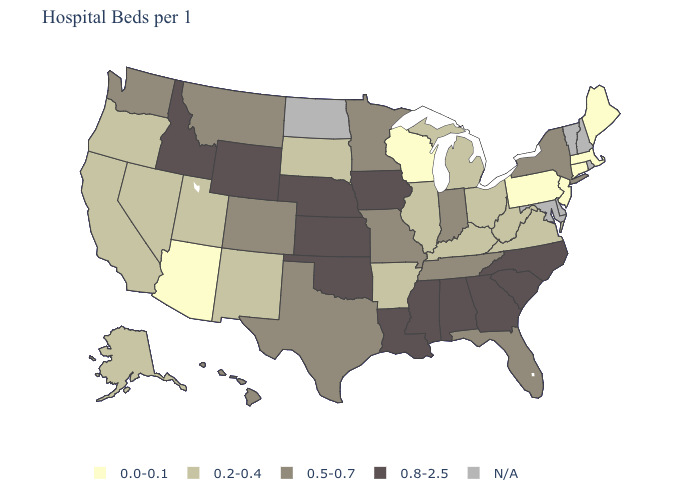What is the highest value in the South ?
Be succinct. 0.8-2.5. Does the map have missing data?
Keep it brief. Yes. Does Connecticut have the lowest value in the Northeast?
Write a very short answer. Yes. Which states have the highest value in the USA?
Quick response, please. Alabama, Georgia, Idaho, Iowa, Kansas, Louisiana, Mississippi, Nebraska, North Carolina, Oklahoma, South Carolina, Wyoming. What is the lowest value in states that border New Hampshire?
Answer briefly. 0.0-0.1. What is the value of Michigan?
Quick response, please. 0.2-0.4. What is the value of South Dakota?
Give a very brief answer. 0.2-0.4. Among the states that border Tennessee , does Georgia have the lowest value?
Write a very short answer. No. Among the states that border Montana , does South Dakota have the lowest value?
Write a very short answer. Yes. What is the highest value in states that border New York?
Keep it brief. 0.0-0.1. Which states have the lowest value in the USA?
Short answer required. Arizona, Connecticut, Maine, Massachusetts, New Jersey, Pennsylvania, Wisconsin. Which states have the lowest value in the USA?
Concise answer only. Arizona, Connecticut, Maine, Massachusetts, New Jersey, Pennsylvania, Wisconsin. What is the value of New Hampshire?
Short answer required. N/A. Does Wisconsin have the lowest value in the MidWest?
Short answer required. Yes. Name the states that have a value in the range 0.2-0.4?
Give a very brief answer. Alaska, Arkansas, California, Illinois, Kentucky, Michigan, Nevada, New Mexico, Ohio, Oregon, South Dakota, Utah, Virginia, West Virginia. 